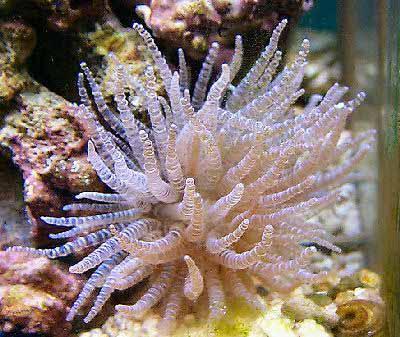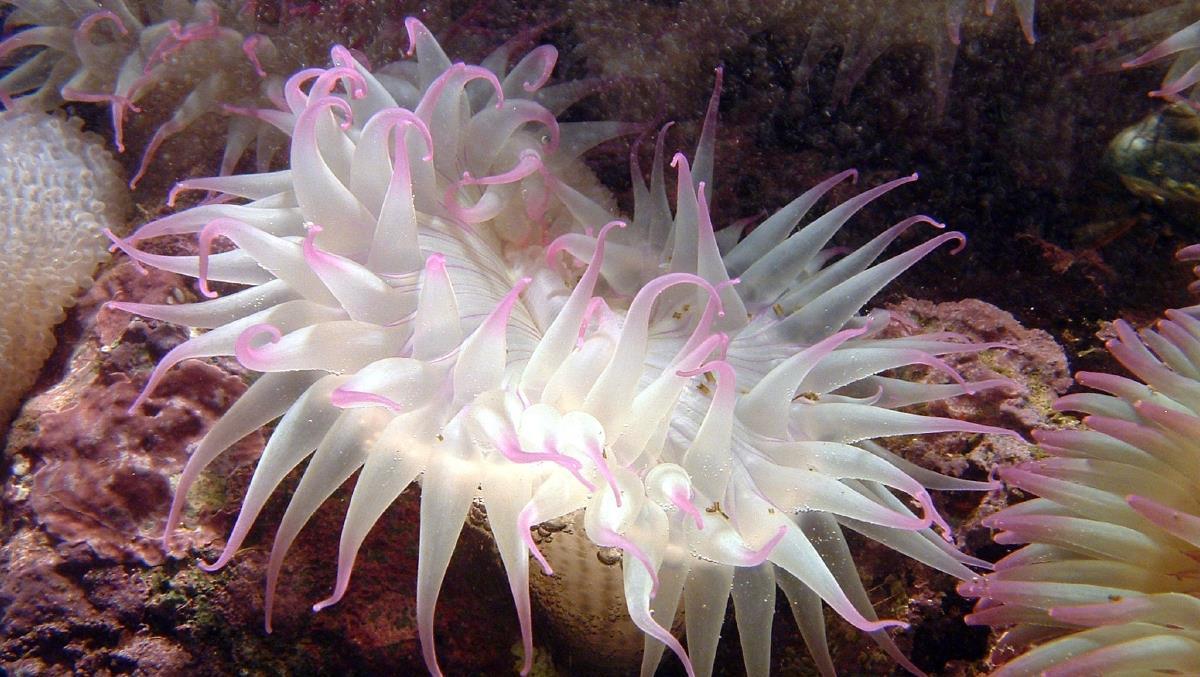The first image is the image on the left, the second image is the image on the right. Assess this claim about the two images: "The sea creature in the right photo has white tentacles with pink tips.". Correct or not? Answer yes or no. Yes. The first image is the image on the left, the second image is the image on the right. Assess this claim about the two images: "The trunk of the anemone can be seen in one of the images.". Correct or not? Answer yes or no. No. 